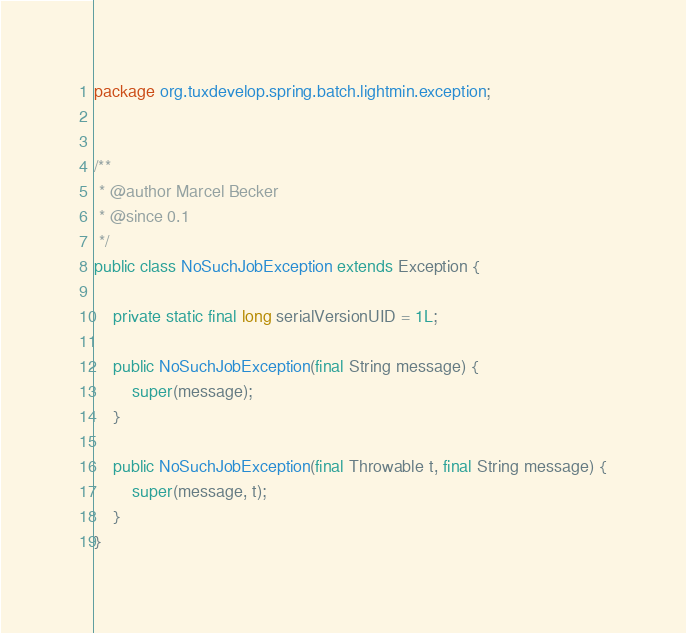<code> <loc_0><loc_0><loc_500><loc_500><_Java_>package org.tuxdevelop.spring.batch.lightmin.exception;


/**
 * @author Marcel Becker
 * @since 0.1
 */
public class NoSuchJobException extends Exception {

    private static final long serialVersionUID = 1L;

    public NoSuchJobException(final String message) {
        super(message);
    }

    public NoSuchJobException(final Throwable t, final String message) {
        super(message, t);
    }
}
</code> 